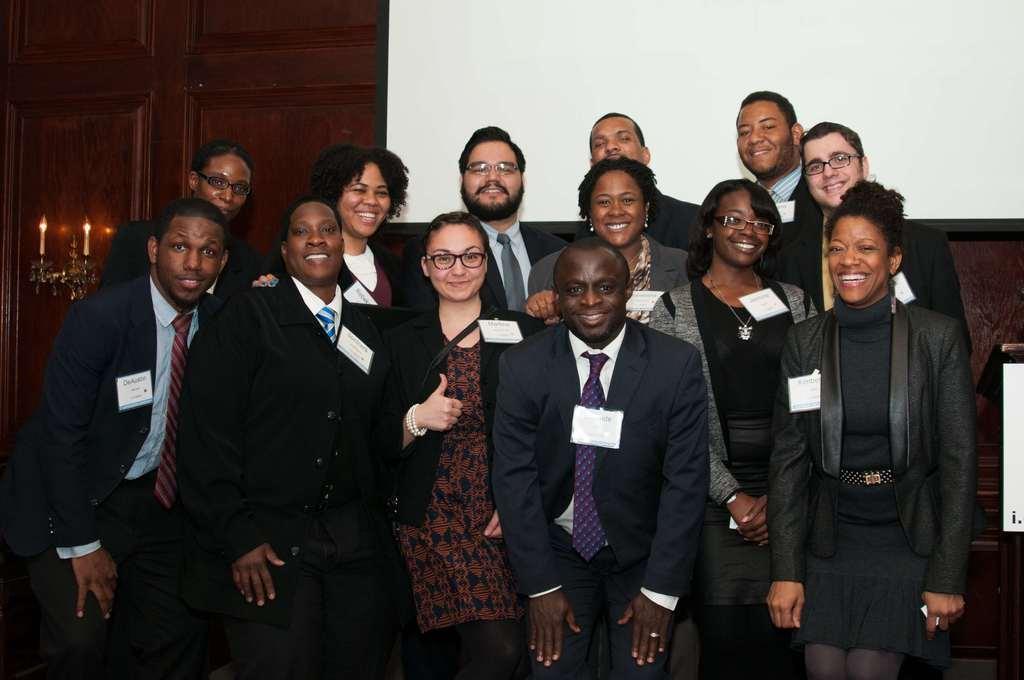How would you summarize this image in a sentence or two? Here we can see group of people posing to a camera and they are smiling. In the background we can see a wall, door, and lights. 